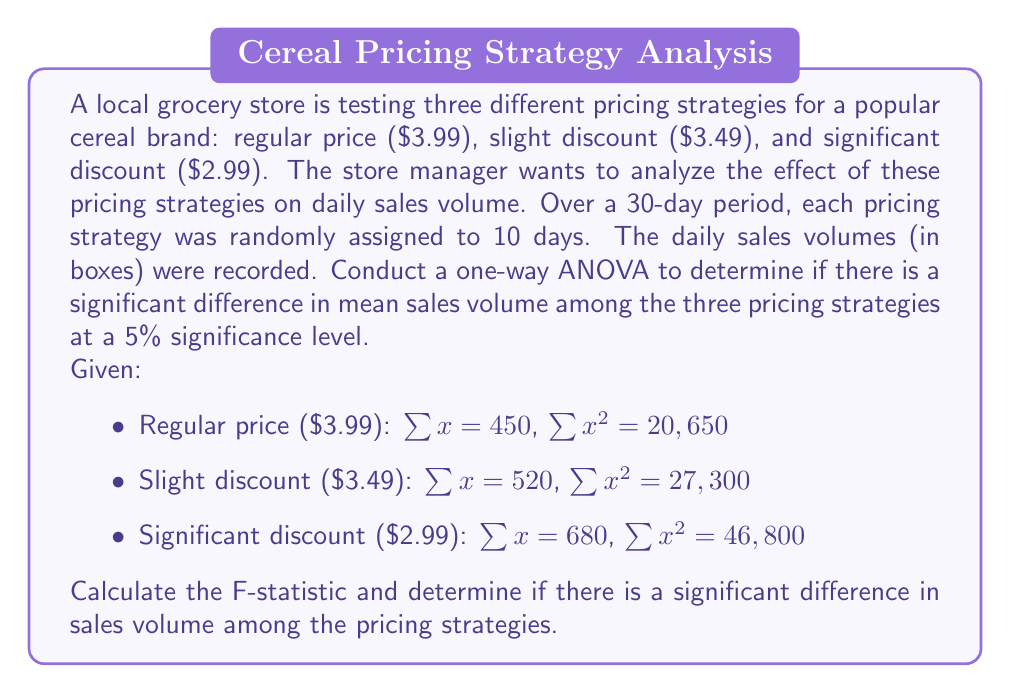Help me with this question. Let's approach this step-by-step:

1) First, we need to calculate the sum of squares:

   Total Sum of Squares (SST):
   $SST = \sum x^2 - \frac{(\sum x)^2}{N}$
   $SST = (20650 + 27300 + 46800) - \frac{(450 + 520 + 680)^2}{30}$
   $SST = 94750 - \frac{1650^2}{30} = 94750 - 90750 = 4000$

2) Between Group Sum of Squares (SSB):
   $SSB = \sum \frac{(\sum x_i)^2}{n_i} - \frac{(\sum x)^2}{N}$
   $SSB = \frac{450^2}{10} + \frac{520^2}{10} + \frac{680^2}{10} - \frac{1650^2}{30}$
   $SSB = 20250 + 27040 + 46240 - 90750 = 2780$

3) Within Group Sum of Squares (SSW):
   $SSW = SST - SSB = 4000 - 2780 = 1220$

4) Degrees of freedom:
   $df_{between} = k - 1 = 3 - 1 = 2$ (where k is the number of groups)
   $df_{within} = N - k = 30 - 3 = 27$
   $df_{total} = N - 1 = 30 - 1 = 29$

5) Mean Square Between (MSB) and Mean Square Within (MSW):
   $MSB = \frac{SSB}{df_{between}} = \frac{2780}{2} = 1390$
   $MSW = \frac{SSW}{df_{within}} = \frac{1220}{27} = 45.19$

6) F-statistic:
   $F = \frac{MSB}{MSW} = \frac{1390}{45.19} = 30.76$

7) Decision:
   At 5% significance level, the critical F-value for $F(2,27)$ is approximately 3.35.
   Since our calculated F-value (30.76) is greater than the critical value (3.35), we reject the null hypothesis.
Answer: The F-statistic is 30.76. Since this is greater than the critical value of 3.35 at the 5% significance level, we conclude that there is a significant difference in mean sales volume among the three pricing strategies. 